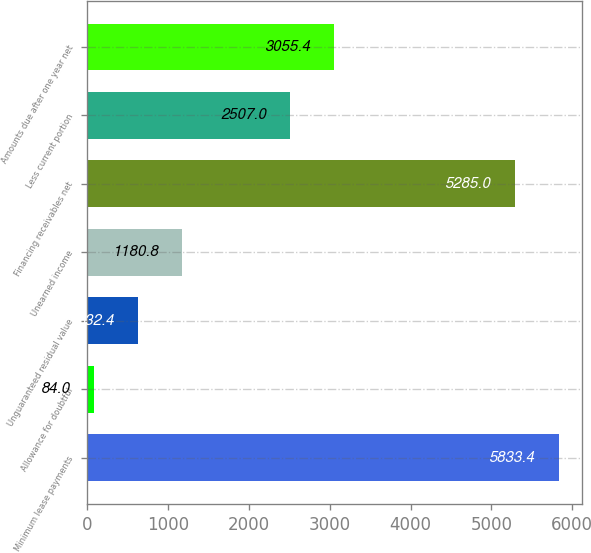Convert chart to OTSL. <chart><loc_0><loc_0><loc_500><loc_500><bar_chart><fcel>Minimum lease payments<fcel>Allowance for doubtful<fcel>Unguaranteed residual value<fcel>Unearned income<fcel>Financing receivables net<fcel>Less current portion<fcel>Amounts due after one year net<nl><fcel>5833.4<fcel>84<fcel>632.4<fcel>1180.8<fcel>5285<fcel>2507<fcel>3055.4<nl></chart> 